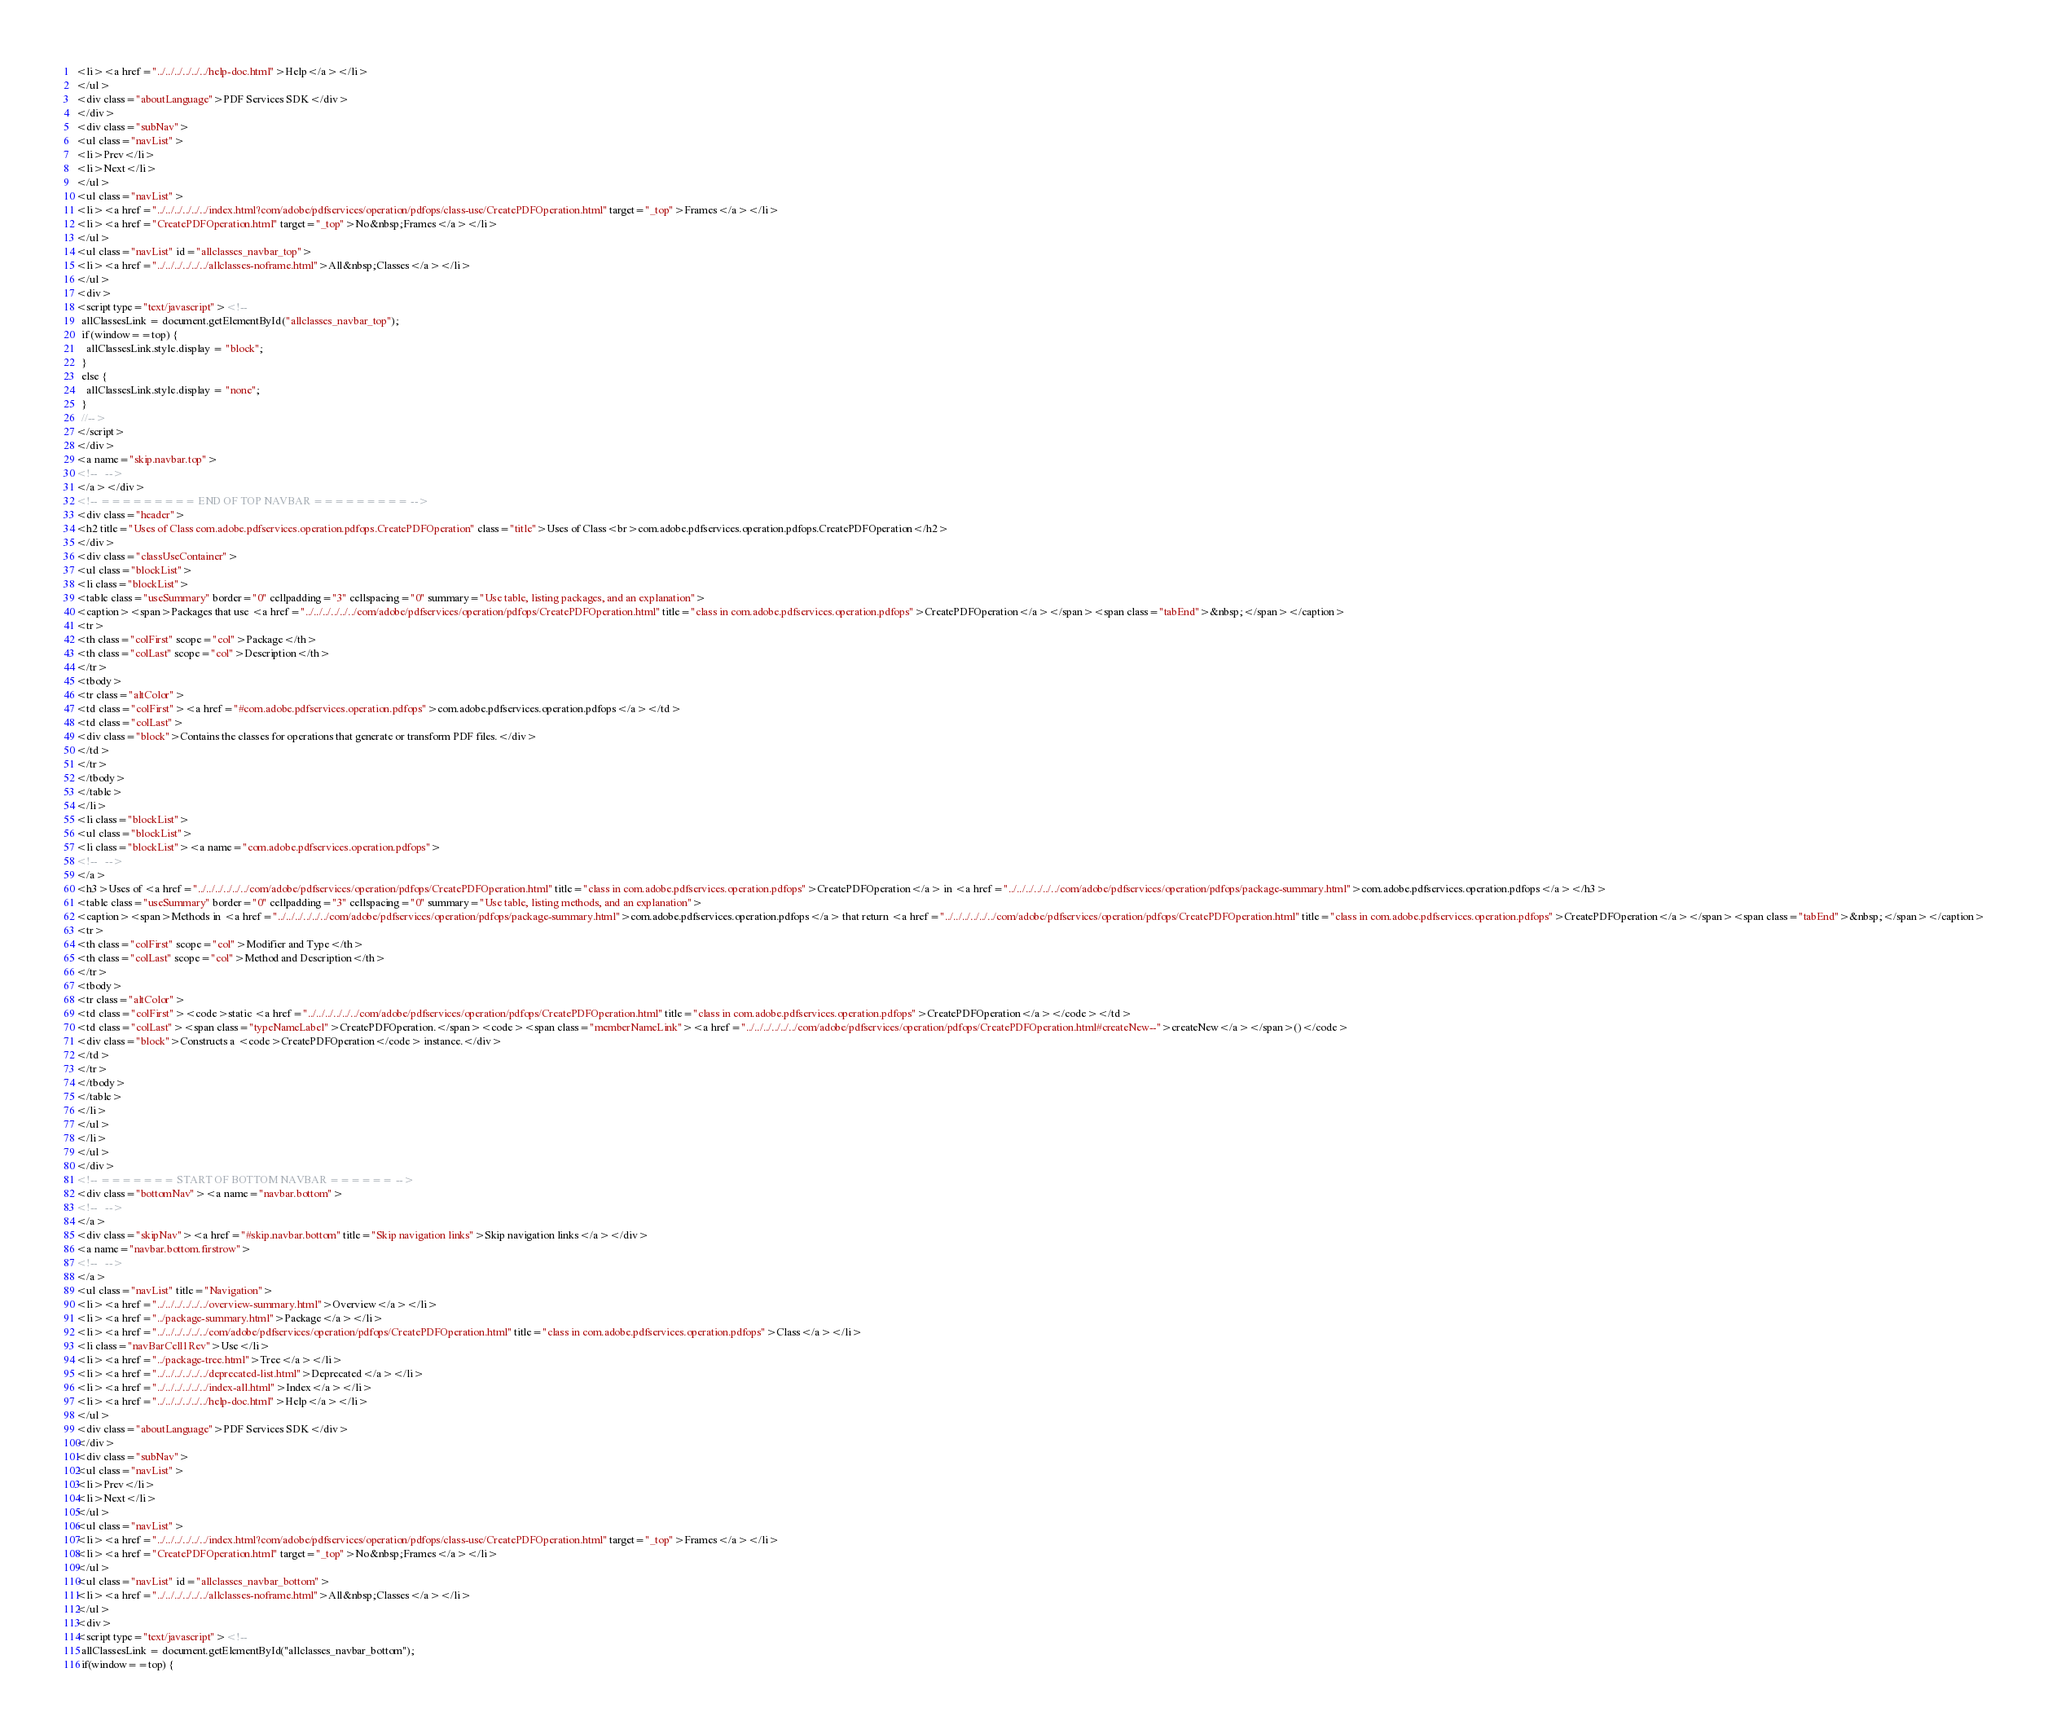Convert code to text. <code><loc_0><loc_0><loc_500><loc_500><_HTML_><li><a href="../../../../../../help-doc.html">Help</a></li>
</ul>
<div class="aboutLanguage">PDF Services SDK</div>
</div>
<div class="subNav">
<ul class="navList">
<li>Prev</li>
<li>Next</li>
</ul>
<ul class="navList">
<li><a href="../../../../../../index.html?com/adobe/pdfservices/operation/pdfops/class-use/CreatePDFOperation.html" target="_top">Frames</a></li>
<li><a href="CreatePDFOperation.html" target="_top">No&nbsp;Frames</a></li>
</ul>
<ul class="navList" id="allclasses_navbar_top">
<li><a href="../../../../../../allclasses-noframe.html">All&nbsp;Classes</a></li>
</ul>
<div>
<script type="text/javascript"><!--
  allClassesLink = document.getElementById("allclasses_navbar_top");
  if(window==top) {
    allClassesLink.style.display = "block";
  }
  else {
    allClassesLink.style.display = "none";
  }
  //-->
</script>
</div>
<a name="skip.navbar.top">
<!--   -->
</a></div>
<!-- ========= END OF TOP NAVBAR ========= -->
<div class="header">
<h2 title="Uses of Class com.adobe.pdfservices.operation.pdfops.CreatePDFOperation" class="title">Uses of Class<br>com.adobe.pdfservices.operation.pdfops.CreatePDFOperation</h2>
</div>
<div class="classUseContainer">
<ul class="blockList">
<li class="blockList">
<table class="useSummary" border="0" cellpadding="3" cellspacing="0" summary="Use table, listing packages, and an explanation">
<caption><span>Packages that use <a href="../../../../../../com/adobe/pdfservices/operation/pdfops/CreatePDFOperation.html" title="class in com.adobe.pdfservices.operation.pdfops">CreatePDFOperation</a></span><span class="tabEnd">&nbsp;</span></caption>
<tr>
<th class="colFirst" scope="col">Package</th>
<th class="colLast" scope="col">Description</th>
</tr>
<tbody>
<tr class="altColor">
<td class="colFirst"><a href="#com.adobe.pdfservices.operation.pdfops">com.adobe.pdfservices.operation.pdfops</a></td>
<td class="colLast">
<div class="block">Contains the classes for operations that generate or transform PDF files.</div>
</td>
</tr>
</tbody>
</table>
</li>
<li class="blockList">
<ul class="blockList">
<li class="blockList"><a name="com.adobe.pdfservices.operation.pdfops">
<!--   -->
</a>
<h3>Uses of <a href="../../../../../../com/adobe/pdfservices/operation/pdfops/CreatePDFOperation.html" title="class in com.adobe.pdfservices.operation.pdfops">CreatePDFOperation</a> in <a href="../../../../../../com/adobe/pdfservices/operation/pdfops/package-summary.html">com.adobe.pdfservices.operation.pdfops</a></h3>
<table class="useSummary" border="0" cellpadding="3" cellspacing="0" summary="Use table, listing methods, and an explanation">
<caption><span>Methods in <a href="../../../../../../com/adobe/pdfservices/operation/pdfops/package-summary.html">com.adobe.pdfservices.operation.pdfops</a> that return <a href="../../../../../../com/adobe/pdfservices/operation/pdfops/CreatePDFOperation.html" title="class in com.adobe.pdfservices.operation.pdfops">CreatePDFOperation</a></span><span class="tabEnd">&nbsp;</span></caption>
<tr>
<th class="colFirst" scope="col">Modifier and Type</th>
<th class="colLast" scope="col">Method and Description</th>
</tr>
<tbody>
<tr class="altColor">
<td class="colFirst"><code>static <a href="../../../../../../com/adobe/pdfservices/operation/pdfops/CreatePDFOperation.html" title="class in com.adobe.pdfservices.operation.pdfops">CreatePDFOperation</a></code></td>
<td class="colLast"><span class="typeNameLabel">CreatePDFOperation.</span><code><span class="memberNameLink"><a href="../../../../../../com/adobe/pdfservices/operation/pdfops/CreatePDFOperation.html#createNew--">createNew</a></span>()</code>
<div class="block">Constructs a <code>CreatePDFOperation</code> instance.</div>
</td>
</tr>
</tbody>
</table>
</li>
</ul>
</li>
</ul>
</div>
<!-- ======= START OF BOTTOM NAVBAR ====== -->
<div class="bottomNav"><a name="navbar.bottom">
<!--   -->
</a>
<div class="skipNav"><a href="#skip.navbar.bottom" title="Skip navigation links">Skip navigation links</a></div>
<a name="navbar.bottom.firstrow">
<!--   -->
</a>
<ul class="navList" title="Navigation">
<li><a href="../../../../../../overview-summary.html">Overview</a></li>
<li><a href="../package-summary.html">Package</a></li>
<li><a href="../../../../../../com/adobe/pdfservices/operation/pdfops/CreatePDFOperation.html" title="class in com.adobe.pdfservices.operation.pdfops">Class</a></li>
<li class="navBarCell1Rev">Use</li>
<li><a href="../package-tree.html">Tree</a></li>
<li><a href="../../../../../../deprecated-list.html">Deprecated</a></li>
<li><a href="../../../../../../index-all.html">Index</a></li>
<li><a href="../../../../../../help-doc.html">Help</a></li>
</ul>
<div class="aboutLanguage">PDF Services SDK</div>
</div>
<div class="subNav">
<ul class="navList">
<li>Prev</li>
<li>Next</li>
</ul>
<ul class="navList">
<li><a href="../../../../../../index.html?com/adobe/pdfservices/operation/pdfops/class-use/CreatePDFOperation.html" target="_top">Frames</a></li>
<li><a href="CreatePDFOperation.html" target="_top">No&nbsp;Frames</a></li>
</ul>
<ul class="navList" id="allclasses_navbar_bottom">
<li><a href="../../../../../../allclasses-noframe.html">All&nbsp;Classes</a></li>
</ul>
<div>
<script type="text/javascript"><!--
  allClassesLink = document.getElementById("allclasses_navbar_bottom");
  if(window==top) {</code> 